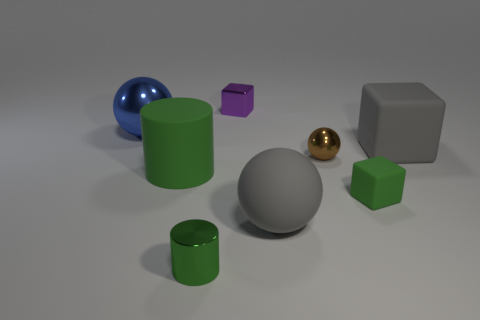Subtract 1 cylinders. How many cylinders are left? 1 Subtract all large spheres. How many spheres are left? 1 Subtract all blocks. How many objects are left? 5 Subtract all red cylinders. Subtract all yellow cubes. How many cylinders are left? 2 Subtract all purple balls. How many green cubes are left? 1 Subtract all brown matte things. Subtract all gray rubber cubes. How many objects are left? 7 Add 2 purple things. How many purple things are left? 3 Add 6 tiny brown spheres. How many tiny brown spheres exist? 7 Add 1 green metallic cylinders. How many objects exist? 9 Subtract 0 yellow cubes. How many objects are left? 8 